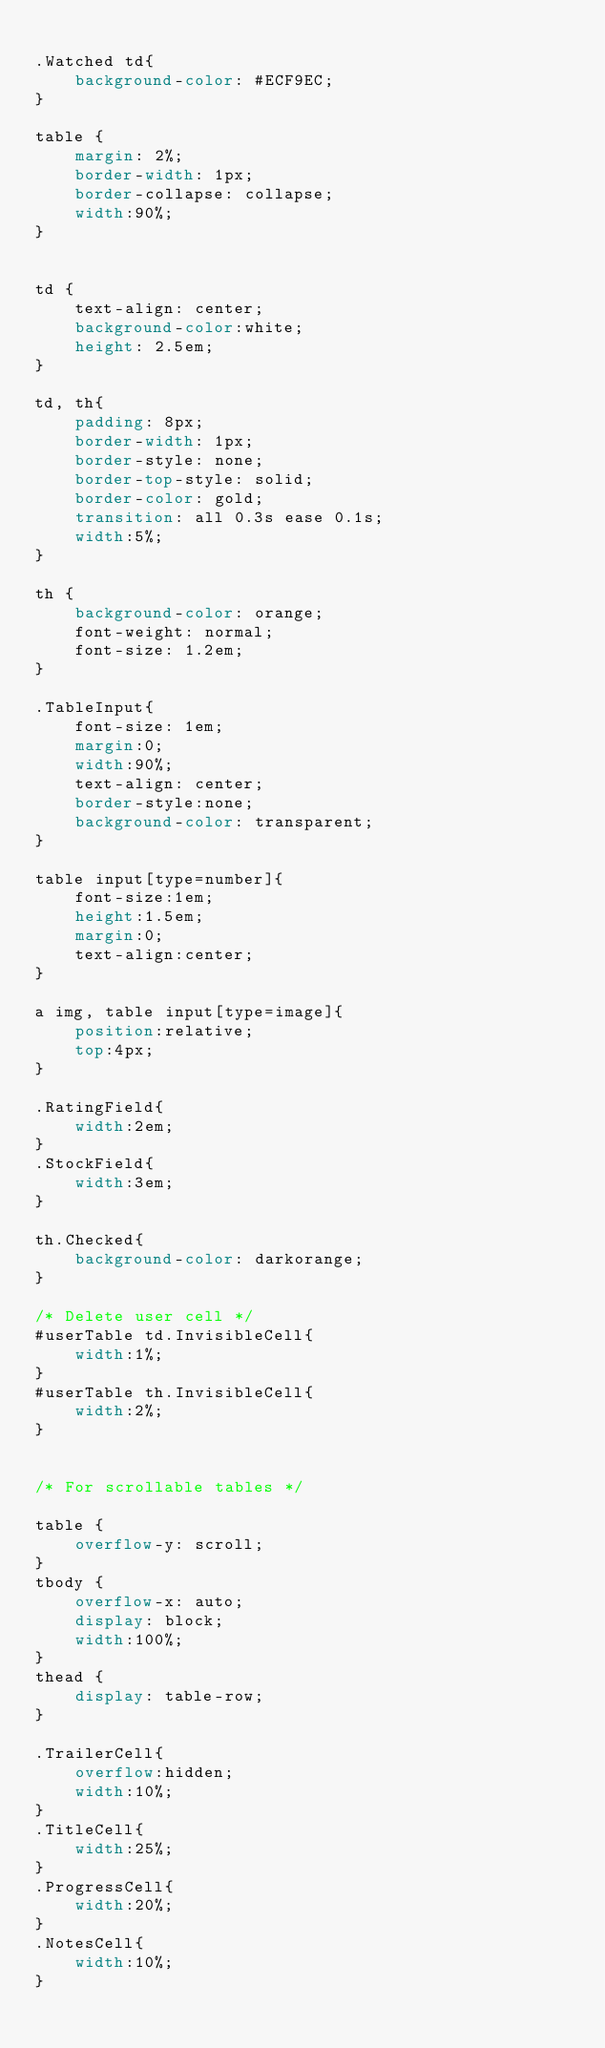Convert code to text. <code><loc_0><loc_0><loc_500><loc_500><_CSS_>
.Watched td{
    background-color: #ECF9EC;
}

table {
    margin: 2%;
    border-width: 1px;
    border-collapse: collapse;
    width:90%;
}


td {
    text-align: center;
    background-color:white;
    height: 2.5em;
}

td, th{
    padding: 8px;
    border-width: 1px;
    border-style: none;
    border-top-style: solid;
    border-color: gold;
    transition: all 0.3s ease 0.1s;
    width:5%;
}

th {
    background-color: orange;
    font-weight: normal;
    font-size: 1.2em;
}

.TableInput{
    font-size: 1em;
    margin:0;
    width:90%;
    text-align: center;
    border-style:none;
    background-color: transparent;
}

table input[type=number]{
    font-size:1em;
    height:1.5em;
    margin:0;
    text-align:center;
}

a img, table input[type=image]{
    position:relative;
    top:4px;
}

.RatingField{
    width:2em;
}
.StockField{
    width:3em;
}

th.Checked{
    background-color: darkorange;
}

/* Delete user cell */
#userTable td.InvisibleCell{
    width:1%;
}
#userTable th.InvisibleCell{
    width:2%;
}


/* For scrollable tables */

table {
    overflow-y: scroll;
}
tbody {
    overflow-x: auto;
    display: block;
    width:100%;
}
thead {
    display: table-row;
}

.TrailerCell{
    overflow:hidden;
    width:10%;
}
.TitleCell{
    width:25%;
}
.ProgressCell{
    width:20%;
}
.NotesCell{
    width:10%;
}</code> 